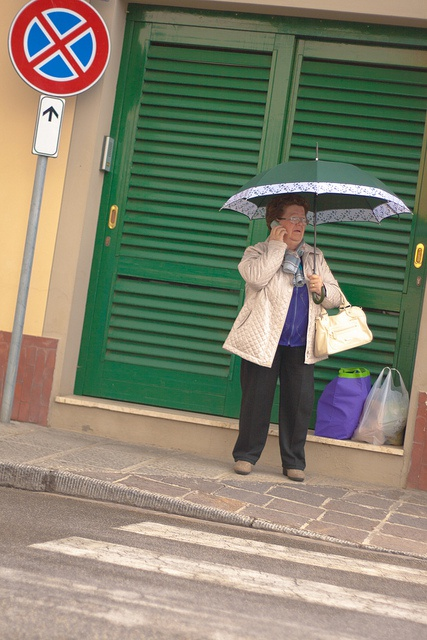Describe the objects in this image and their specific colors. I can see people in tan, black, and ivory tones, umbrella in tan, teal, black, lavender, and gray tones, handbag in tan, darkgray, and gray tones, handbag in tan and ivory tones, and cell phone in tan and gray tones in this image. 